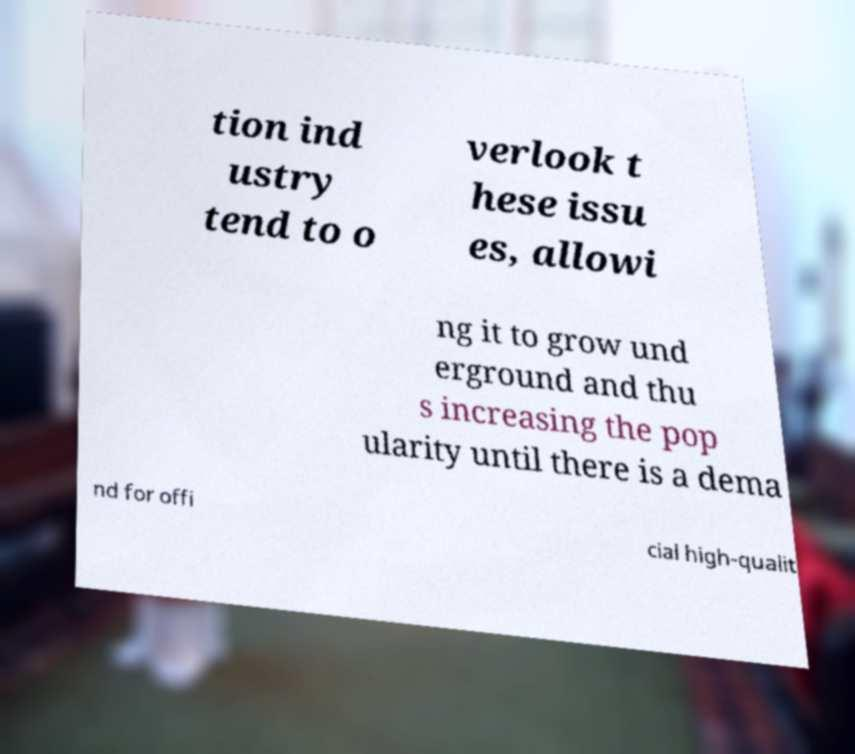What messages or text are displayed in this image? I need them in a readable, typed format. tion ind ustry tend to o verlook t hese issu es, allowi ng it to grow und erground and thu s increasing the pop ularity until there is a dema nd for offi cial high-qualit 